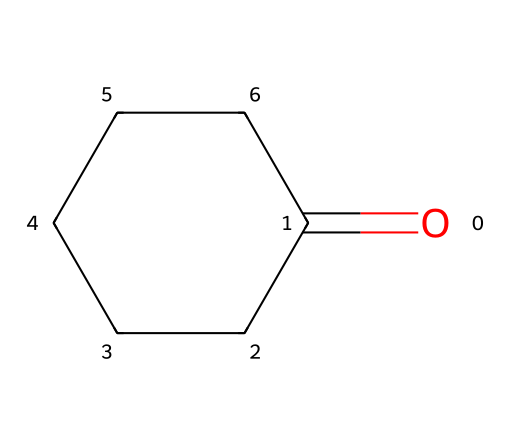What is the molecular formula of cyclohexanone? To derive the molecular formula from the SMILES representation, count the types and numbers of atoms: 6 carbon atoms (from "C" and the ring notation), 10 hydrogen atoms (assuming saturation in a cyclic compound), and 1 oxygen atom (from the "O=). The molecular formula is thus C6H10O.
Answer: C6H10O How many carbon atoms are in cyclohexanone? By examining the SMILES, "C" appears six times as part of the structure, indicating that there are six carbon atoms present in the cyclohexanone molecule.
Answer: 6 What is the functional group present in cyclohexanone? The SMILES notation shows "O=" which indicates a carbonyl group (C=O) is present. This functional group characterizes cyclohexanone as a ketone, specifically.
Answer: ketone How many hydrogen atoms are attached to the carbon of the carbonyl group in cyclohexanone? In the structure, the carbon of the carbonyl is double-bonded to oxygen and is part of a ring. In cyclic compounds, each carbon typically binds to enough hydrogens to make four bonds in total. This specific carbon has only one hydrogen attached due to the double bond to the oxygen.
Answer: 1 Does cyclohexanone exhibit isomerism? Considering the nature of cycloalkanes and their functional groups, cyclohexanone can have geometric isomers due to the presence of a carbonyl group. However, given its structure, there are no cis-trans isomers, but it can exhibit structural isomerism with other compounds that have the same molecular formula.
Answer: Yes What type of ring structure does cyclohexanone have? The structure outlined in the SMILES indicates a cyclohexane ring with ketone functionalization. It consists of six members in the ring formation, which is characteristic of cyclohexane derivatives.
Answer: six-membered 